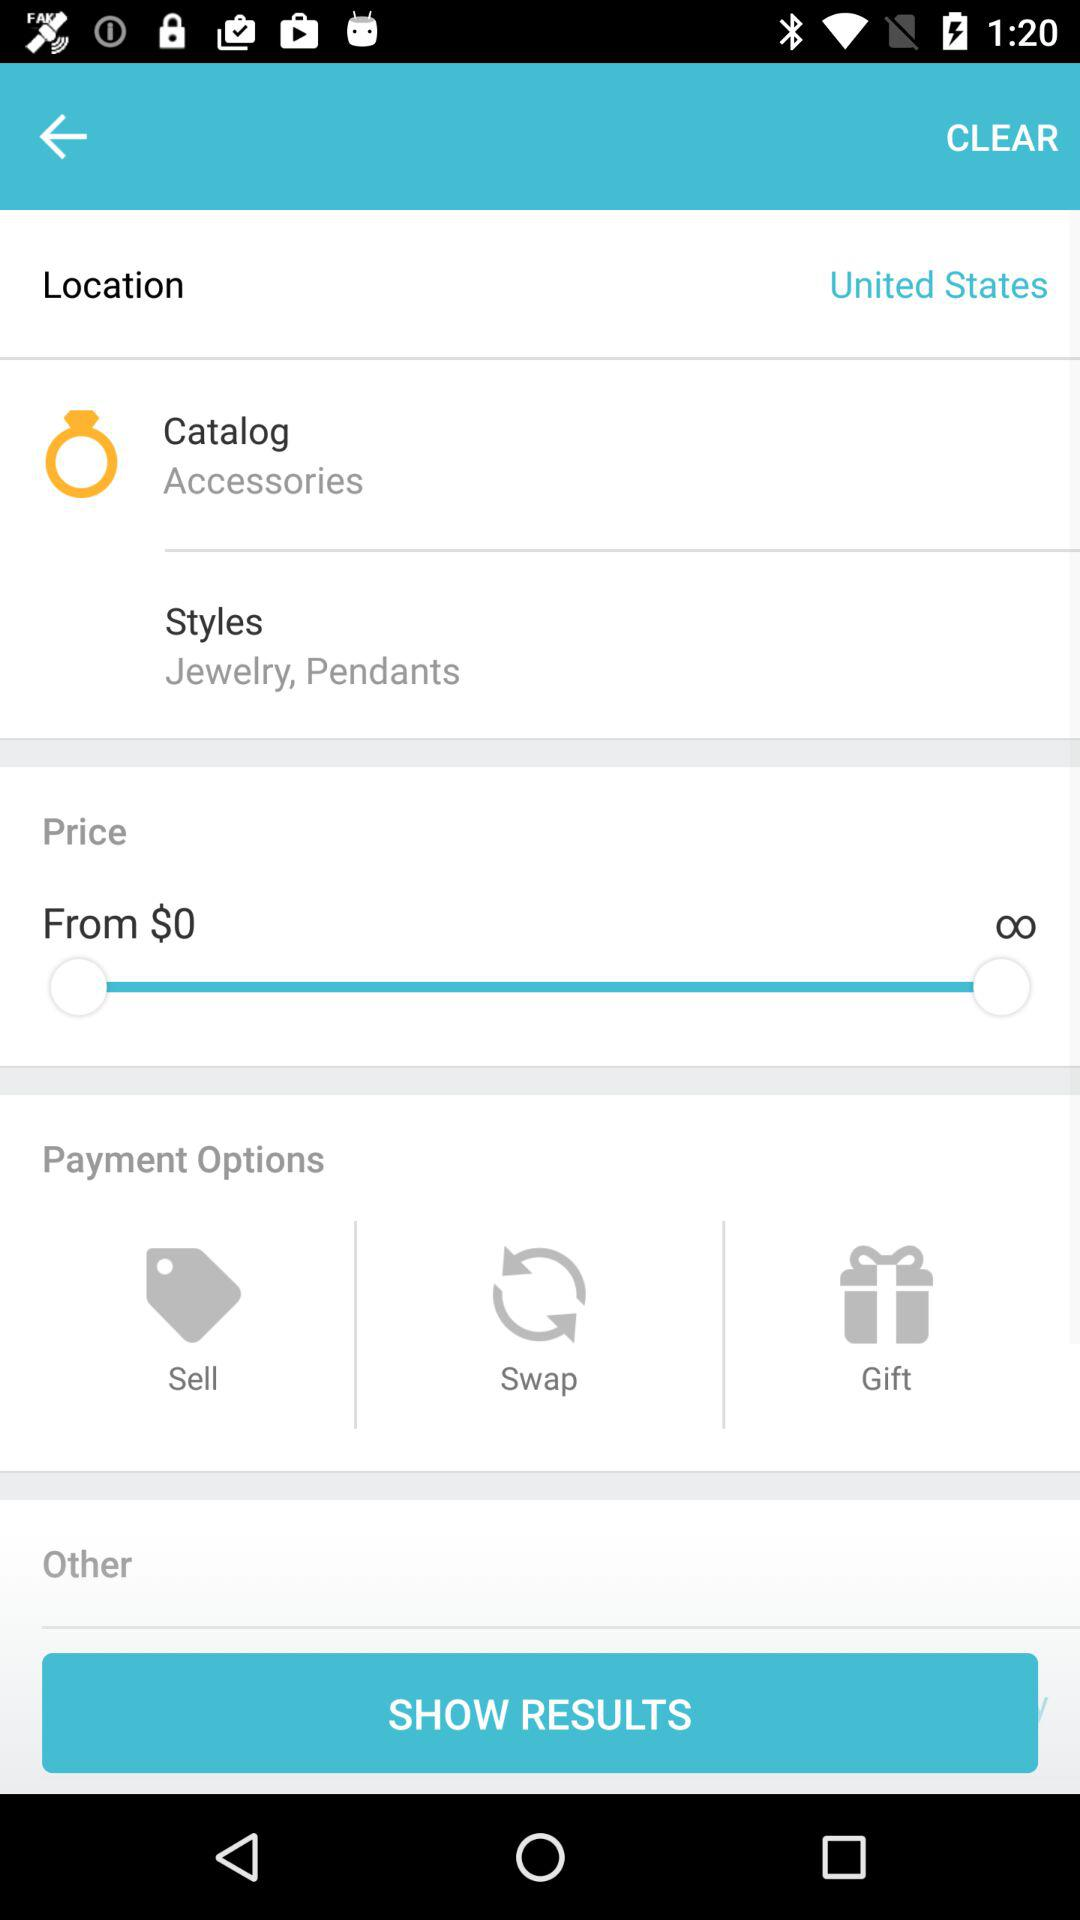What is the location? The location is the United States. 